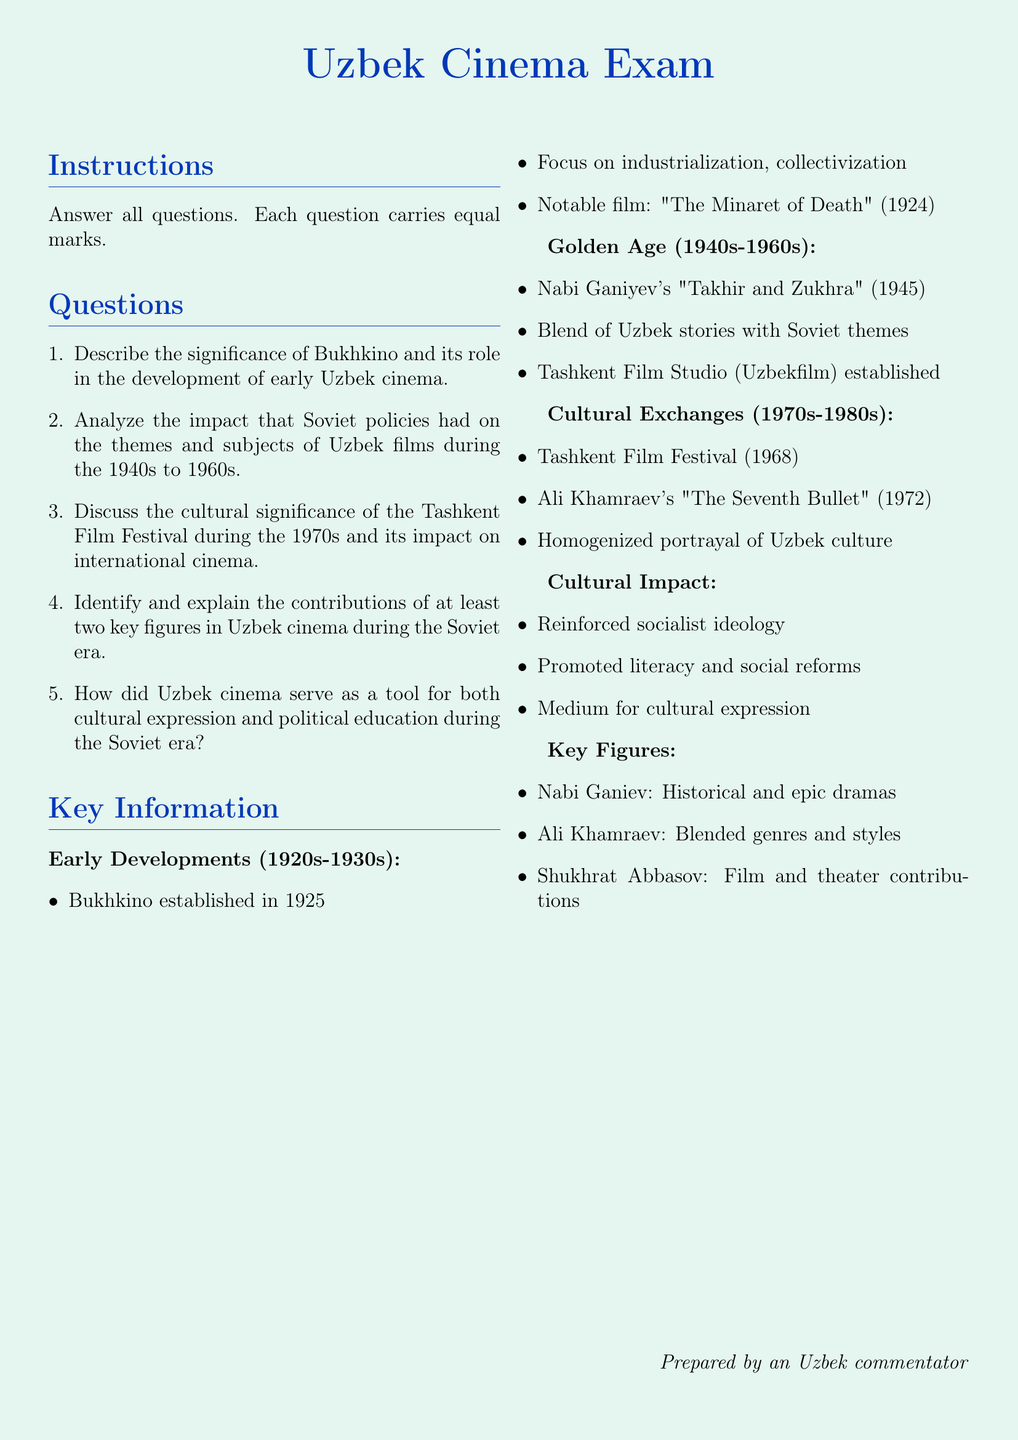What year was Bukhkino established? Bukhkino was founded in 1925, which marks an important point in early Uzbek cinema.
Answer: 1925 What is the title of Nabi Ganiyev's notable film? The notable film by Nabi Ganiyev is "Takhir and Zukhra," which was released in 1945, highlighting the Golden Age of Uzbek cinema.
Answer: "Takhir and Zukhra" How many key figures are identified in the document? The document identifies three key figures in Uzbek cinema during the Soviet era, highlighting their contributions.
Answer: Three What does the Tashkent Film Festival signify in the document? The Tashkent Film Festival, established in 1968, represents a significant event in Uzbek cinema that impacted international cinema during the 1970s.
Answer: Cultural significance What is the main theme of Uzbek cinema during the Golden Age? The main theme during the Golden Age involved a blend of Uzbek stories with Soviet themes, reflecting the cultural dynamics of the era.
Answer: Blend of stories Who directed "The Seventh Bullet"? "The Seventh Bullet," a notable film during the Soviet era, was directed by Ali Khamraev, who significantly contributed to Uzbek cinema.
Answer: Ali Khamraev What cultural impact did Uzbek cinema have according to the document? The document states that Uzbek cinema reinforced socialist ideology while promoting literacy and social reforms among the populace.
Answer: Reinforced socialist ideology What role did Uzbek cinema play in the Soviet era? Uzbek cinema served as a tool for cultural expression and political education, highlighting its multifaceted influence during the Soviet era.
Answer: Cultural expression and political education 